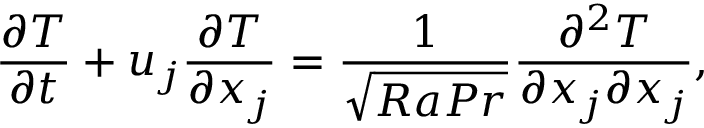<formula> <loc_0><loc_0><loc_500><loc_500>\frac { \partial T } { \partial t } + u _ { j } \frac { \partial T } { \partial x _ { j } } = \frac { 1 } { \sqrt { R a P r } } \frac { \partial ^ { 2 } T } { \partial x _ { j } \partial x _ { j } } ,</formula> 